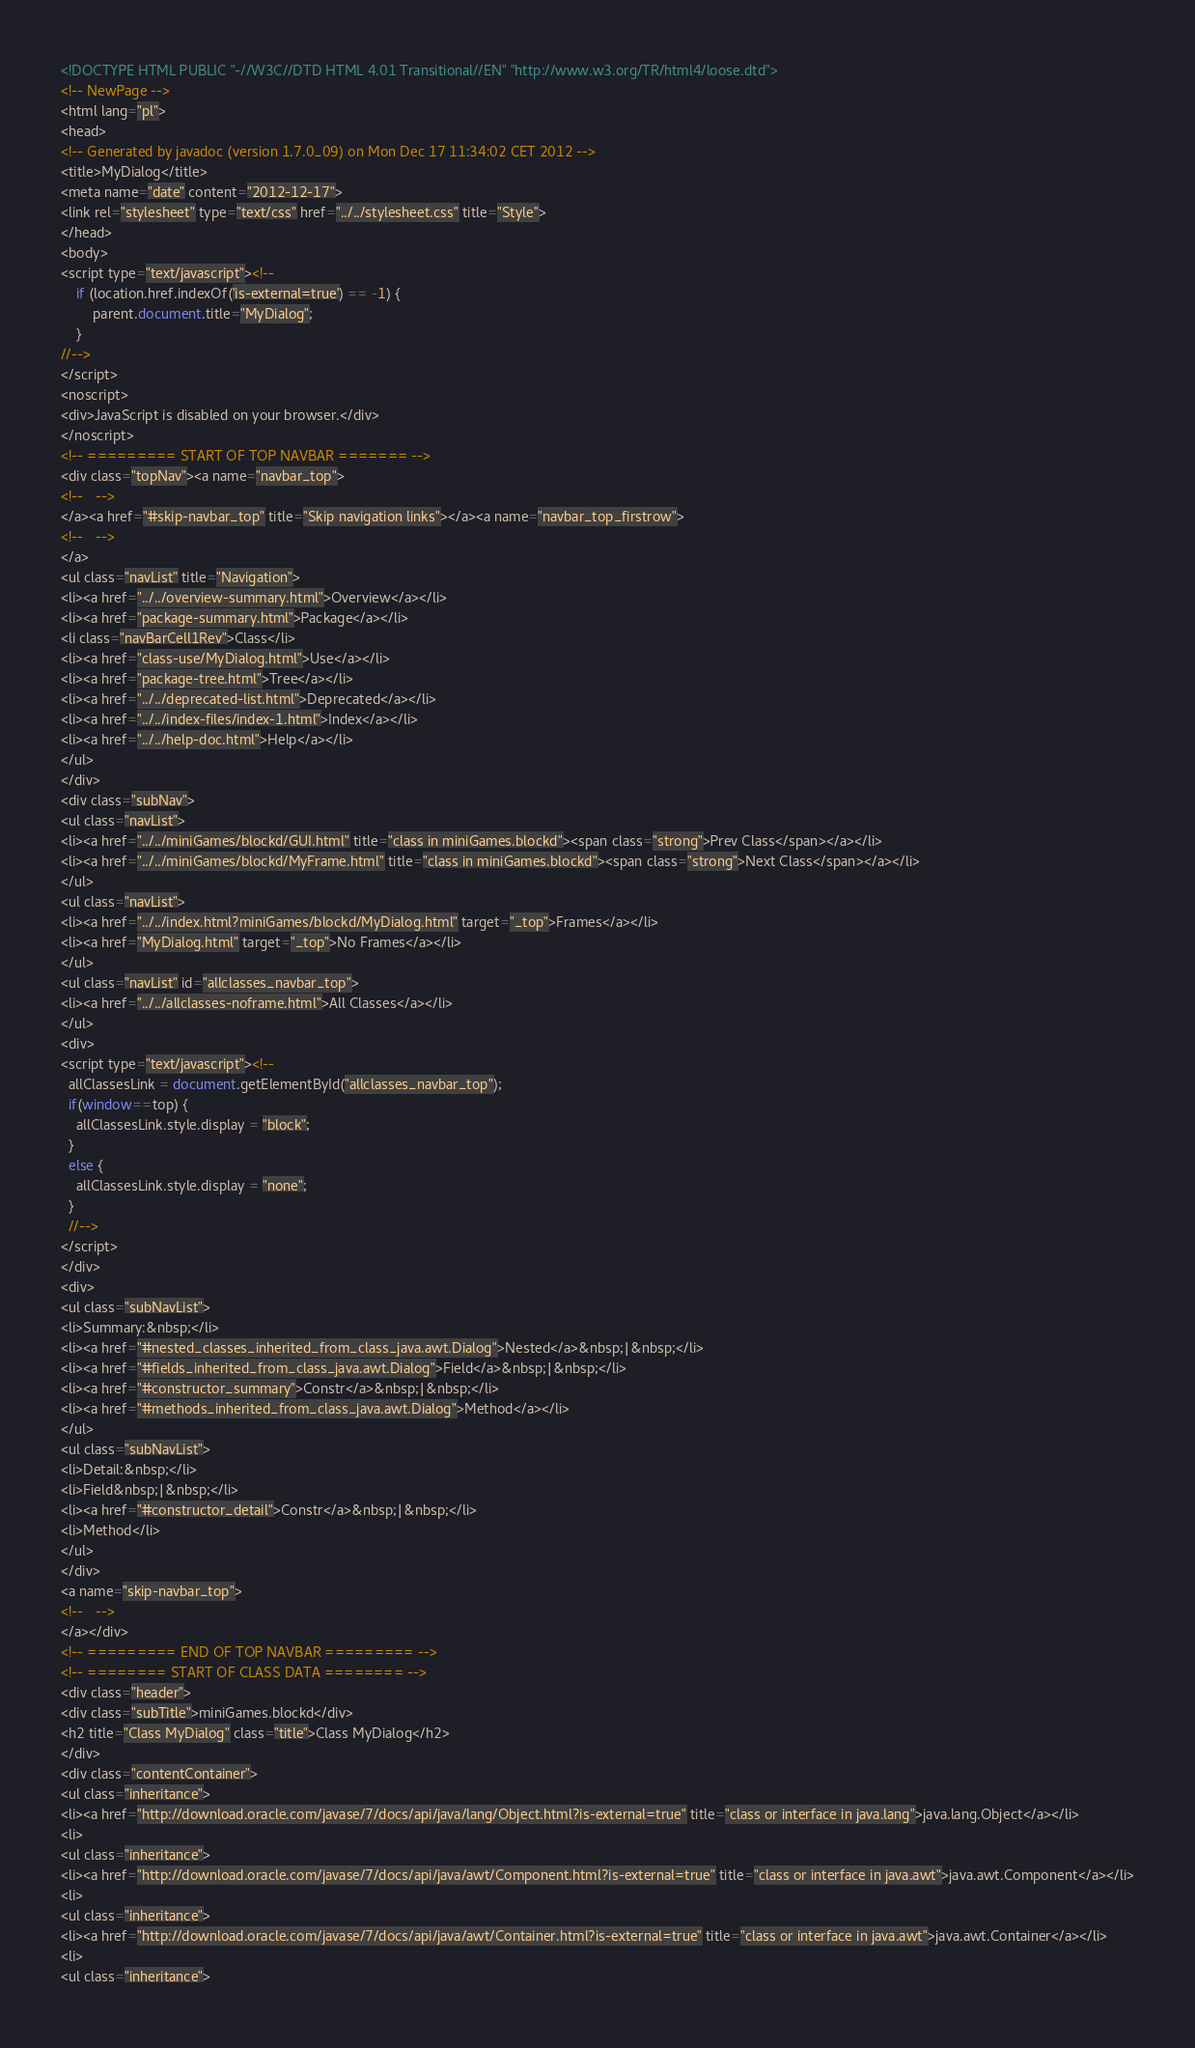Convert code to text. <code><loc_0><loc_0><loc_500><loc_500><_HTML_><!DOCTYPE HTML PUBLIC "-//W3C//DTD HTML 4.01 Transitional//EN" "http://www.w3.org/TR/html4/loose.dtd">
<!-- NewPage -->
<html lang="pl">
<head>
<!-- Generated by javadoc (version 1.7.0_09) on Mon Dec 17 11:34:02 CET 2012 -->
<title>MyDialog</title>
<meta name="date" content="2012-12-17">
<link rel="stylesheet" type="text/css" href="../../stylesheet.css" title="Style">
</head>
<body>
<script type="text/javascript"><!--
    if (location.href.indexOf('is-external=true') == -1) {
        parent.document.title="MyDialog";
    }
//-->
</script>
<noscript>
<div>JavaScript is disabled on your browser.</div>
</noscript>
<!-- ========= START OF TOP NAVBAR ======= -->
<div class="topNav"><a name="navbar_top">
<!--   -->
</a><a href="#skip-navbar_top" title="Skip navigation links"></a><a name="navbar_top_firstrow">
<!--   -->
</a>
<ul class="navList" title="Navigation">
<li><a href="../../overview-summary.html">Overview</a></li>
<li><a href="package-summary.html">Package</a></li>
<li class="navBarCell1Rev">Class</li>
<li><a href="class-use/MyDialog.html">Use</a></li>
<li><a href="package-tree.html">Tree</a></li>
<li><a href="../../deprecated-list.html">Deprecated</a></li>
<li><a href="../../index-files/index-1.html">Index</a></li>
<li><a href="../../help-doc.html">Help</a></li>
</ul>
</div>
<div class="subNav">
<ul class="navList">
<li><a href="../../miniGames/blockd/GUI.html" title="class in miniGames.blockd"><span class="strong">Prev Class</span></a></li>
<li><a href="../../miniGames/blockd/MyFrame.html" title="class in miniGames.blockd"><span class="strong">Next Class</span></a></li>
</ul>
<ul class="navList">
<li><a href="../../index.html?miniGames/blockd/MyDialog.html" target="_top">Frames</a></li>
<li><a href="MyDialog.html" target="_top">No Frames</a></li>
</ul>
<ul class="navList" id="allclasses_navbar_top">
<li><a href="../../allclasses-noframe.html">All Classes</a></li>
</ul>
<div>
<script type="text/javascript"><!--
  allClassesLink = document.getElementById("allclasses_navbar_top");
  if(window==top) {
    allClassesLink.style.display = "block";
  }
  else {
    allClassesLink.style.display = "none";
  }
  //-->
</script>
</div>
<div>
<ul class="subNavList">
<li>Summary:&nbsp;</li>
<li><a href="#nested_classes_inherited_from_class_java.awt.Dialog">Nested</a>&nbsp;|&nbsp;</li>
<li><a href="#fields_inherited_from_class_java.awt.Dialog">Field</a>&nbsp;|&nbsp;</li>
<li><a href="#constructor_summary">Constr</a>&nbsp;|&nbsp;</li>
<li><a href="#methods_inherited_from_class_java.awt.Dialog">Method</a></li>
</ul>
<ul class="subNavList">
<li>Detail:&nbsp;</li>
<li>Field&nbsp;|&nbsp;</li>
<li><a href="#constructor_detail">Constr</a>&nbsp;|&nbsp;</li>
<li>Method</li>
</ul>
</div>
<a name="skip-navbar_top">
<!--   -->
</a></div>
<!-- ========= END OF TOP NAVBAR ========= -->
<!-- ======== START OF CLASS DATA ======== -->
<div class="header">
<div class="subTitle">miniGames.blockd</div>
<h2 title="Class MyDialog" class="title">Class MyDialog</h2>
</div>
<div class="contentContainer">
<ul class="inheritance">
<li><a href="http://download.oracle.com/javase/7/docs/api/java/lang/Object.html?is-external=true" title="class or interface in java.lang">java.lang.Object</a></li>
<li>
<ul class="inheritance">
<li><a href="http://download.oracle.com/javase/7/docs/api/java/awt/Component.html?is-external=true" title="class or interface in java.awt">java.awt.Component</a></li>
<li>
<ul class="inheritance">
<li><a href="http://download.oracle.com/javase/7/docs/api/java/awt/Container.html?is-external=true" title="class or interface in java.awt">java.awt.Container</a></li>
<li>
<ul class="inheritance"></code> 